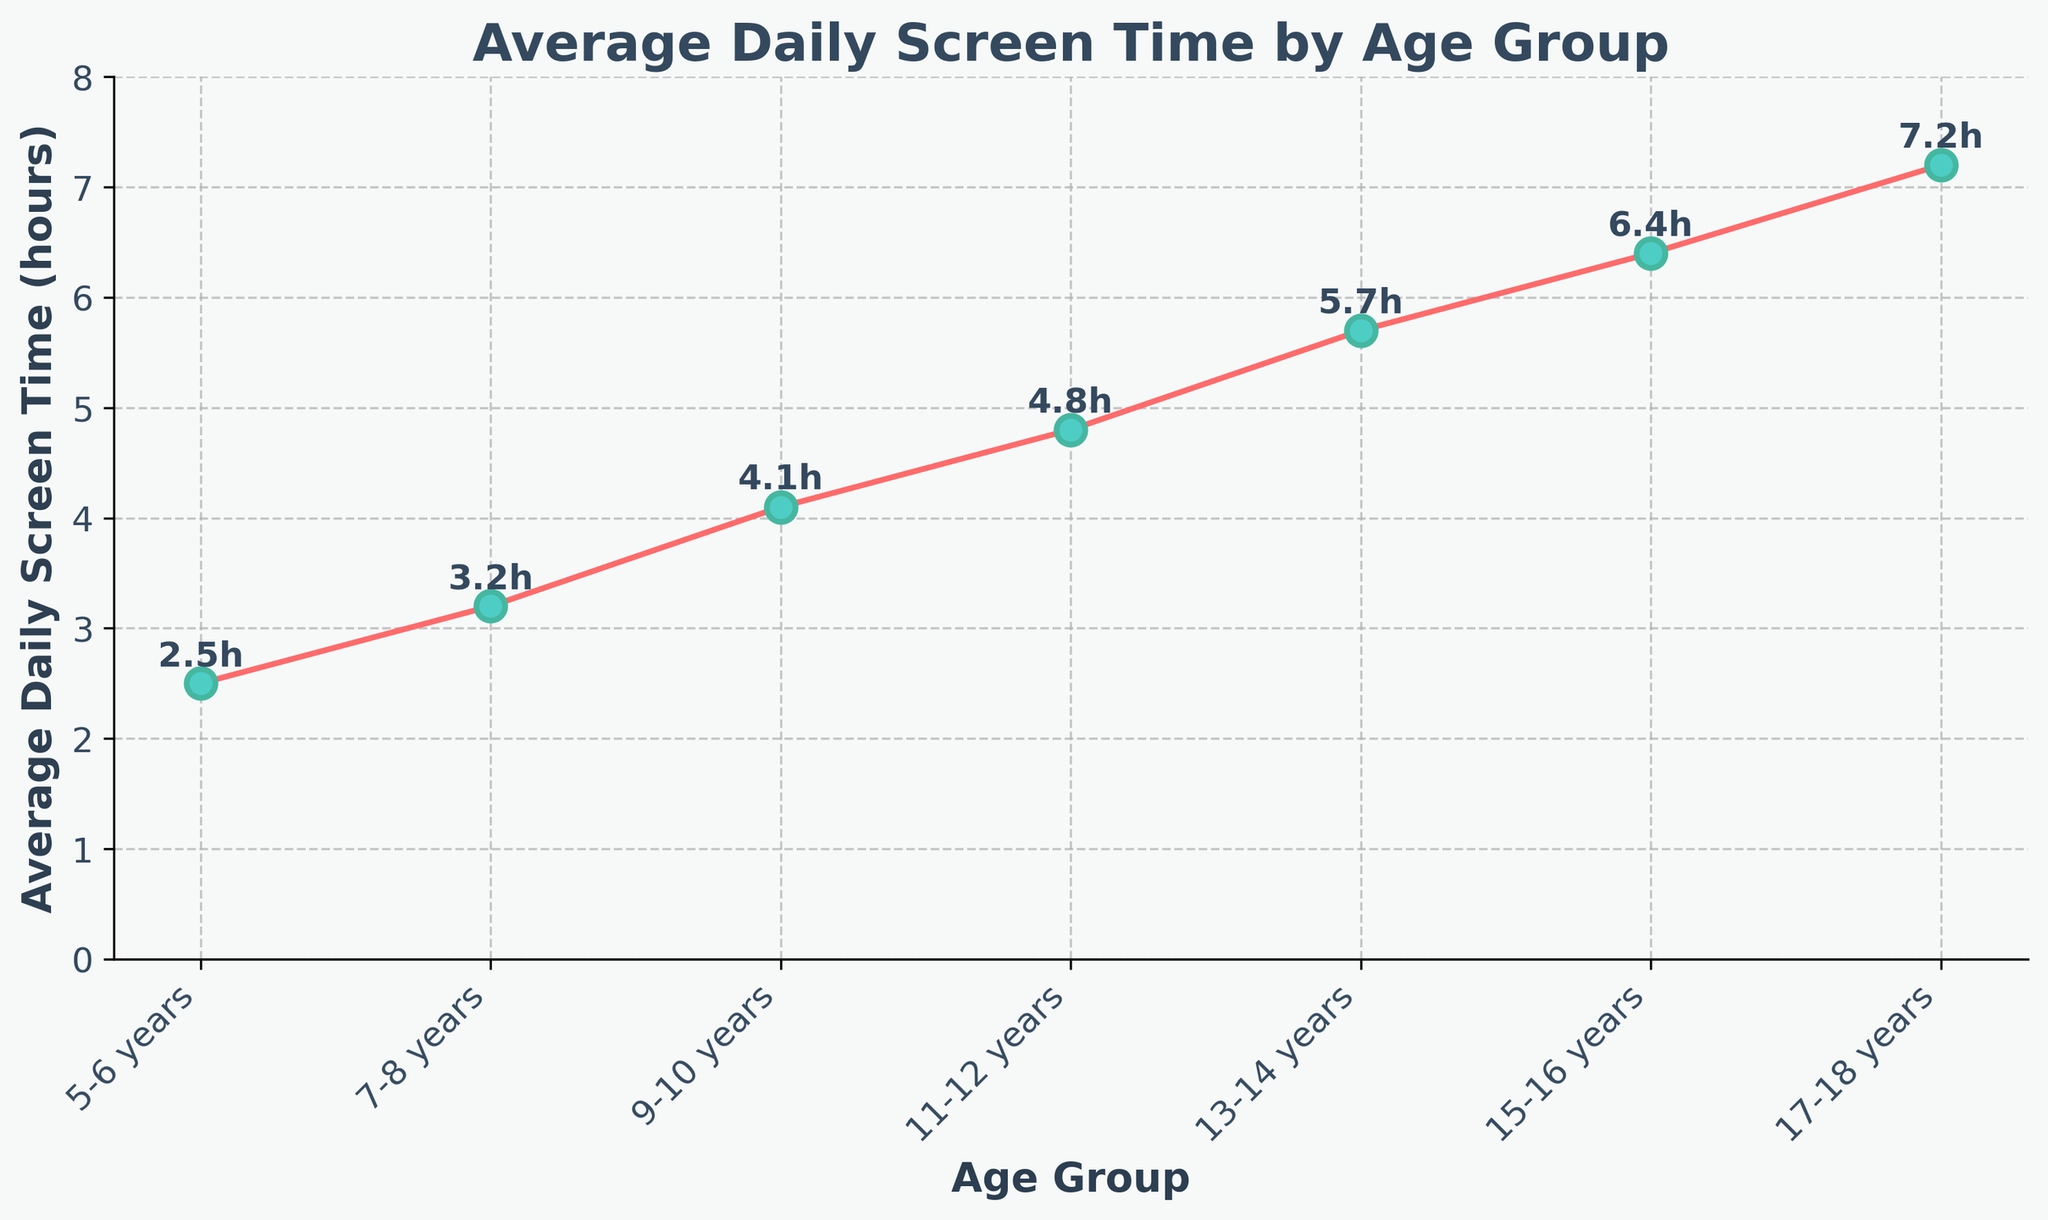What is the average daily screen time for children aged 9-10 years? Look at the data point for the age group 9-10 years and read the value on the y-axis.
Answer: 4.1 hours Which age group has the highest average daily screen time? Identify the highest point on the line chart and read off the corresponding age group from the x-axis.
Answer: 17-18 years How much more screen time do 13-14 year olds have compared to 5-6 year olds? Subtract the average screen time for 5-6 years from the average screen time for 13-14 years (5.7 - 2.5).
Answer: 3.2 hours What is the difference in screen time between the youngest and oldest age groups? Find the average screen time for 5-6 years and 17-18 years, then subtract the former from the latter (7.2 - 2.5).
Answer: 4.7 hours Which age groups have an average daily screen time greater than 4 hours? Read off the data points which have a value on the y-axis greater than 4 hours and identify their corresponding age groups.
Answer: 9-10 years, 11-12 years, 13-14 years, 15-16 years, 17-18 years What is the average screen time for children aged 11-12 years and 13-14 years? Add the average screen time values for 11-12 years and 13-14 years, then divide by 2 ((4.8 + 5.7) / 2).
Answer: 5.25 hours Between which consecutive age groups is the increase in screen time the greatest? Look at the differences between the screen time values of successive age groups and identify the largest difference (7-8 years to 9-10 years is 4.1 - 3.2 = 0.9).
Answer: 13-14 years to 15-16 years Is the screen time for 15-16 year olds closer to that of 13-14 year olds or 17-18 year olds? Compare the differences: (6.4 - 5.7) and (7.2 - 6.4).
Answer: Closer to 17-18 year olds How does the screen time change as the children get older? Observe the trend of the line chart from the left to the right side and describe the general direction.
Answer: It increases 